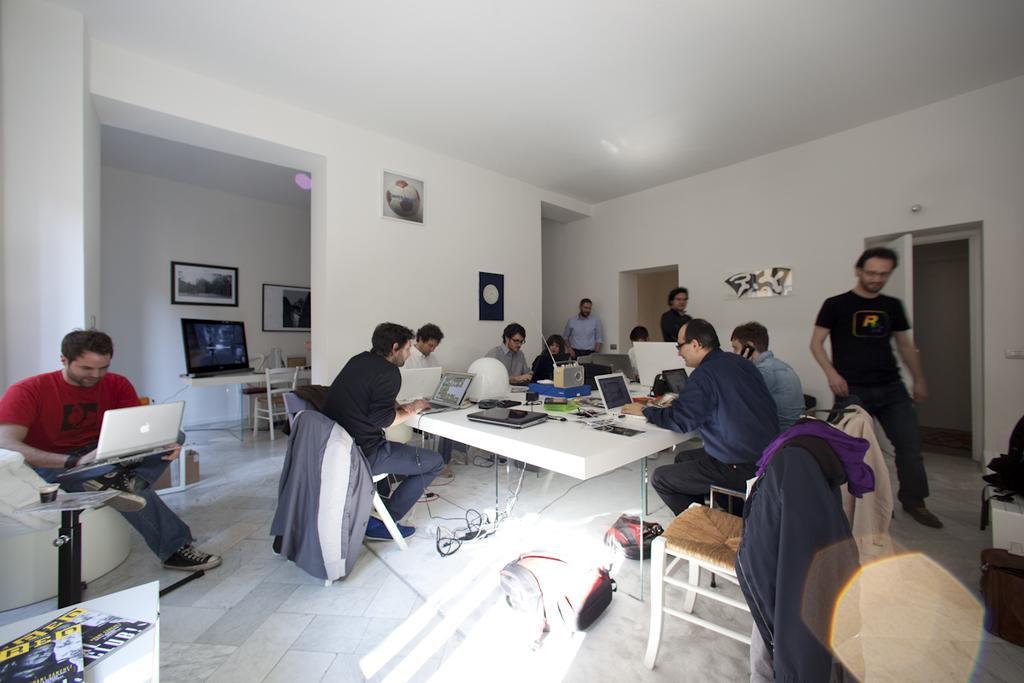How would you summarize this image in a sentence or two? On the background we can see photo frames, posters over a wall. We can see doors here. On the table we can see television, laptops and fm radio. On the floor we can see bags, box, wires. Here we can see persons sitting on chairs in front of a table and working. We can see three persons standing here. 